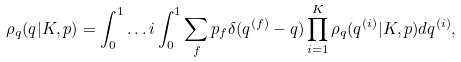<formula> <loc_0><loc_0><loc_500><loc_500>\rho _ { q } ( q | K , p ) = \int _ { 0 } ^ { 1 } \dots i \int _ { 0 } ^ { 1 } \sum _ { f } p _ { f } \delta ( q ^ { ( f ) } - q ) \prod _ { i = 1 } ^ { K } \rho _ { q } ( q ^ { ( i ) } | K , p ) d q ^ { ( i ) } ,</formula> 